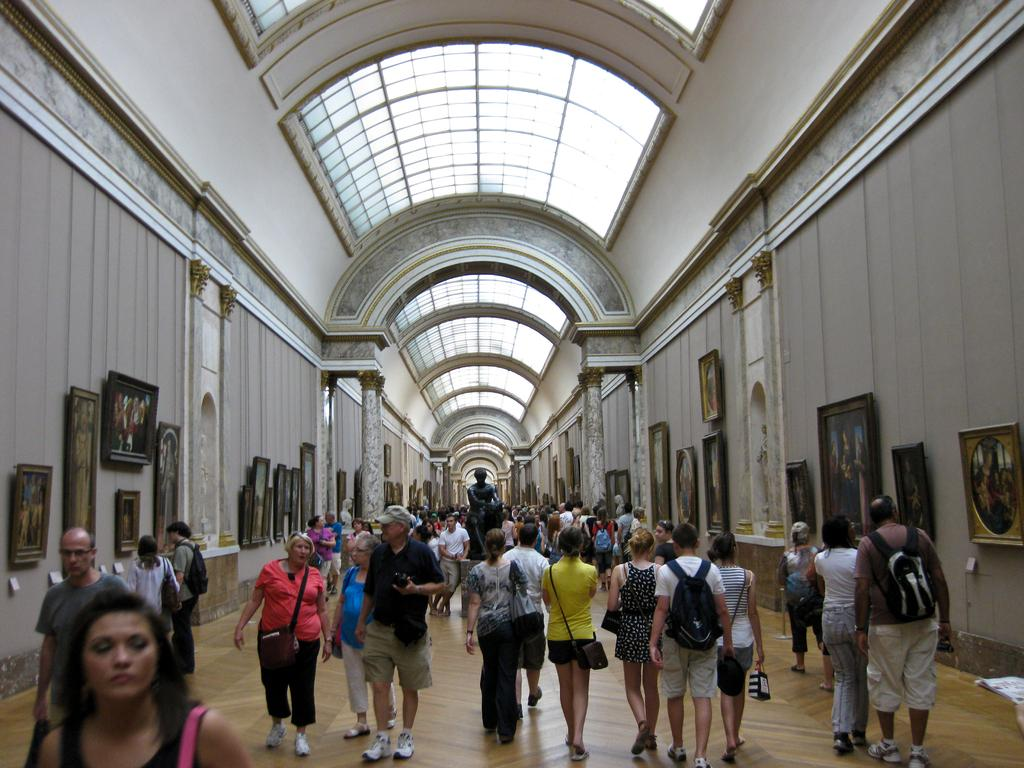Who or what can be seen in the image? There are people in the image. What is the surface that the people are standing on? There is a floor visible in the image. What decorative elements are present on the walls? There are frames on the walls in the image. What architectural features can be seen in the image? There are pillars in the image. What type of artwork is present in the image? There is a sculpture on a platform in the image. What is visible at the top of the image? There is a roof visible at the top of the image. How many sisters are present in the image? There is no mention of sisters in the image, so we cannot determine the number of sisters present. 